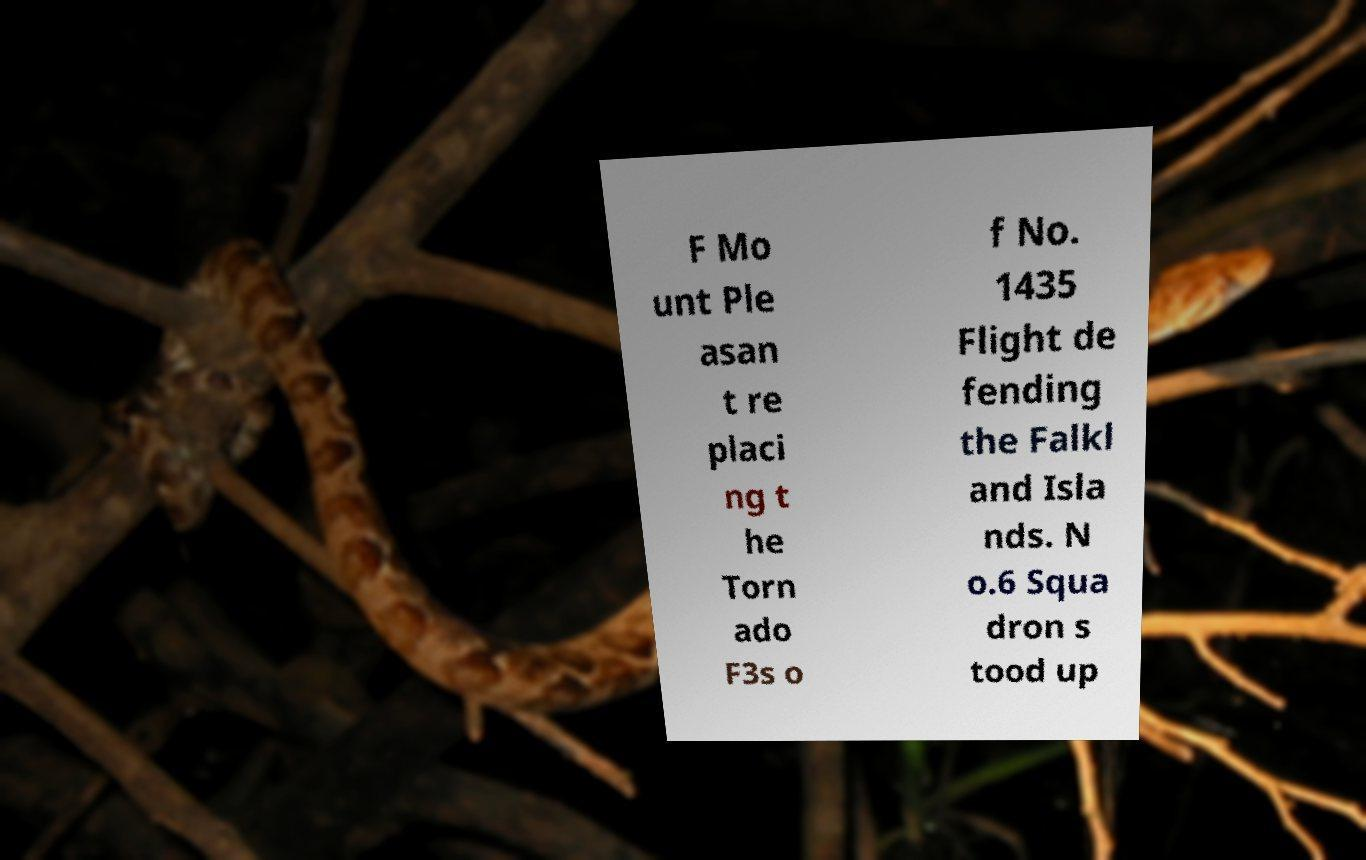Could you assist in decoding the text presented in this image and type it out clearly? F Mo unt Ple asan t re placi ng t he Torn ado F3s o f No. 1435 Flight de fending the Falkl and Isla nds. N o.6 Squa dron s tood up 